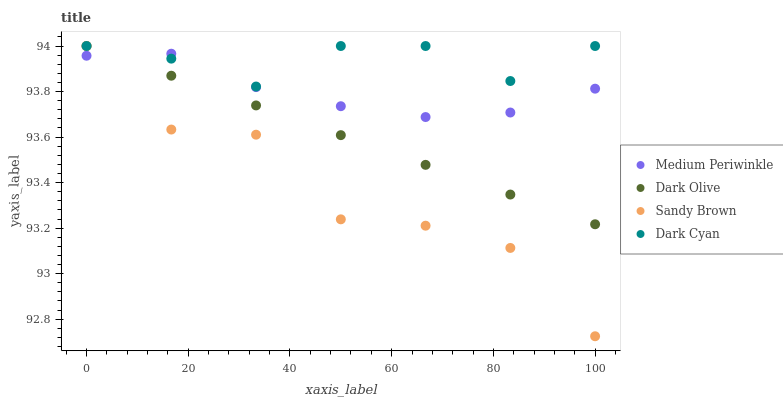Does Sandy Brown have the minimum area under the curve?
Answer yes or no. Yes. Does Dark Cyan have the maximum area under the curve?
Answer yes or no. Yes. Does Dark Olive have the minimum area under the curve?
Answer yes or no. No. Does Dark Olive have the maximum area under the curve?
Answer yes or no. No. Is Dark Olive the smoothest?
Answer yes or no. Yes. Is Sandy Brown the roughest?
Answer yes or no. Yes. Is Sandy Brown the smoothest?
Answer yes or no. No. Is Dark Olive the roughest?
Answer yes or no. No. Does Sandy Brown have the lowest value?
Answer yes or no. Yes. Does Dark Olive have the lowest value?
Answer yes or no. No. Does Dark Olive have the highest value?
Answer yes or no. Yes. Does Medium Periwinkle have the highest value?
Answer yes or no. No. Does Sandy Brown intersect Medium Periwinkle?
Answer yes or no. Yes. Is Sandy Brown less than Medium Periwinkle?
Answer yes or no. No. Is Sandy Brown greater than Medium Periwinkle?
Answer yes or no. No. 